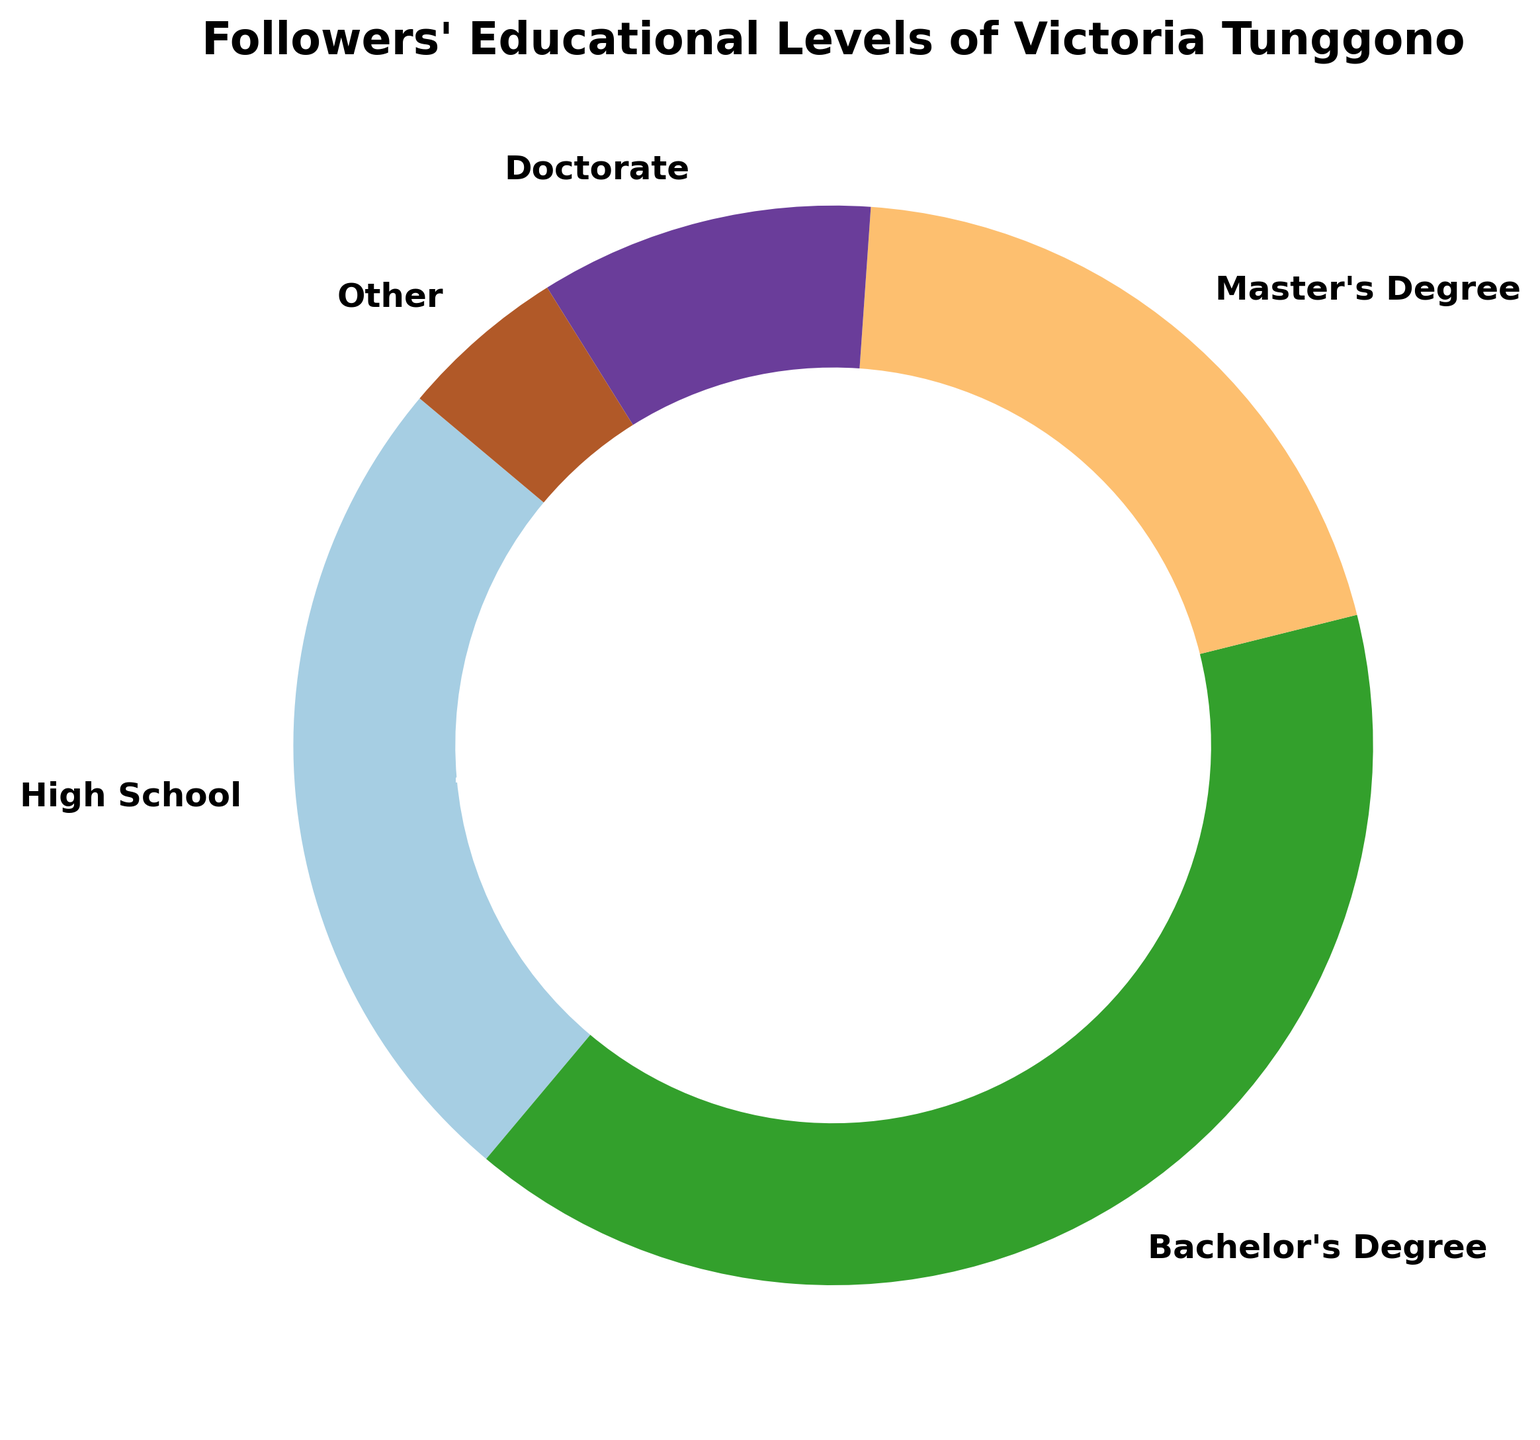What educational level makes up the largest percentage among Victoria Tunggono's followers? From the pie chart, the section labeled "Bachelor's Degree" is the largest, showing 40%. This indicates that followers with a Bachelor's Degree make up the largest percentage.
Answer: Bachelor's Degree Which educational level has the smallest representation among Victoria Tunggono's followers? The pie chart shows a small segment labeled "Other," which has a percentage of 5%. This indicates that "Other" has the smallest representation.
Answer: Other What is the combined percentage of followers who have a Bachelor's Degree and a Master's Degree? The pie chart shows the percentages as 40% for Bachelor's Degree and 20% for Master's Degree. Adding these together gives 40% + 20% = 60%.
Answer: 60% How much larger is the percentage of followers with a Bachelor's Degree compared to those with a Doctorate? The pie chart shows 40% for Bachelor's Degree and 10% for Doctorate. The difference is 40% - 10% = 30%.
Answer: 30% What is the total percentage of followers with at least a Master’s Degree? The pie chart shows 20% for Master's Degree and 10% for Doctorate. Adding these together gives 20% + 10% = 30%.
Answer: 30% Which two educational levels together make up the same percentage as those with a Bachelor's Degree? From the pie chart, followers with a Bachelor's Degree take up 40%. Adding the percentages of High School (25%) and Other (5%) gives 25% + 5% = 30%, which is not enough. Combining Master's Degree (20%) and Doctorate (10%) gives 20% + 10% = 30%. Hence, Bachelor's (40%) can be matched by combining High School (25%) and Master’s Degree (20%) as 25% + 20% = 45% which is close to Bachelor’s 40%.
Answer: High School and Master’s Degree If Victoria Tunggono’s followers numbered 1,000, how many of them are Doctorate holders? The pie chart shows that 10% of followers are Doctorate holders. For 1,000 followers: 1,000 * 10% = 100.
Answer: 100 How does the percentage of followers with a High School education compare to those with a Master's Degree? The pie chart shows 25% for High School and 20% for Master's Degree. 25% is larger than 20%, so followers with a High School education have a higher percentage than those with a Master's.
Answer: High School is higher Which wedge in the pie chart is colored similarly to the segment for Master's Degree? The pie chart’s color palette is continuous, but each segment has a unique shade. Therefore, looking for exact matches visually might be misleading. The color for the segment labeled “Master's Degree” should be visually checked to identify similarity.
Answer: Check visually What is the average percentage of followers for each educational level? Summing all the percentages given in the pie chart: 25% + 40% + 20% + 10% + 5% = 100%. There are 5 educational levels. The average is 100%/5 = 20%.
Answer: 20% 